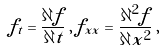<formula> <loc_0><loc_0><loc_500><loc_500>f _ { t } = \frac { \partial f } { \partial t } \, , \, f _ { x x } = \frac { \partial ^ { 2 } f } { \partial x ^ { 2 } } \, ,</formula> 